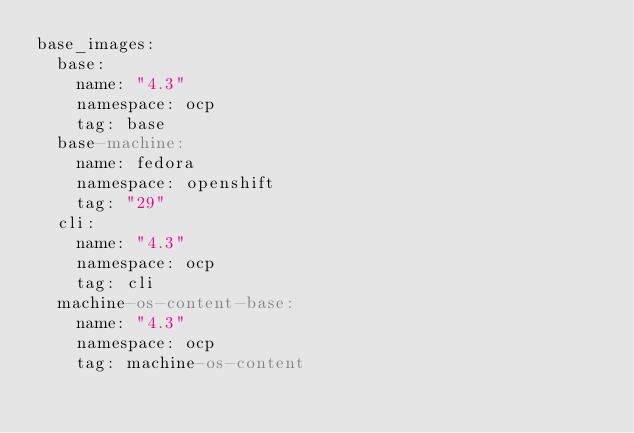<code> <loc_0><loc_0><loc_500><loc_500><_YAML_>base_images:
  base:
    name: "4.3"
    namespace: ocp
    tag: base
  base-machine:
    name: fedora
    namespace: openshift
    tag: "29"
  cli:
    name: "4.3"
    namespace: ocp
    tag: cli
  machine-os-content-base:
    name: "4.3"
    namespace: ocp
    tag: machine-os-content</code> 